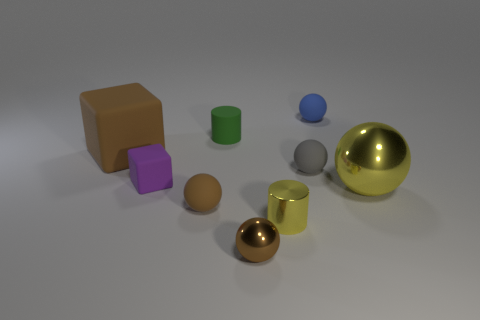How many brown spheres must be subtracted to get 1 brown spheres? 1 Subtract all brown cylinders. How many brown spheres are left? 2 Subtract all tiny metallic spheres. How many spheres are left? 4 Subtract all yellow balls. How many balls are left? 4 Subtract all cylinders. How many objects are left? 7 Subtract all gray spheres. Subtract all red cylinders. How many spheres are left? 4 Subtract all blue spheres. Subtract all small matte cylinders. How many objects are left? 7 Add 2 tiny purple matte things. How many tiny purple matte things are left? 3 Add 8 small gray objects. How many small gray objects exist? 9 Subtract 1 green cylinders. How many objects are left? 8 